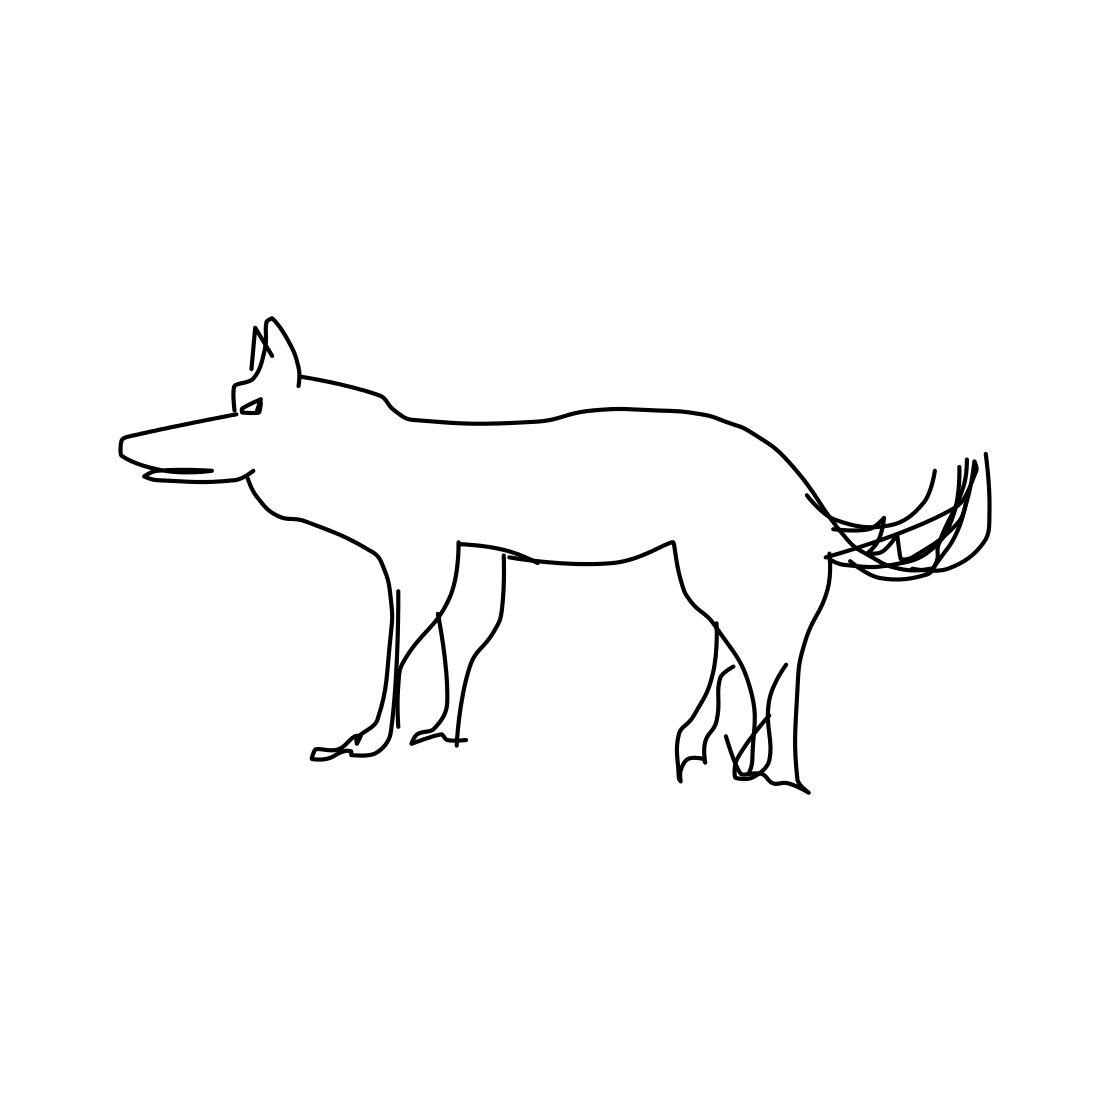In the scene, is a dog in it? Indeed, the image shows a simple line drawing of a dog, depicted in profile view with a discernible head, body, legs, and tail, characteristic of canine representations. 